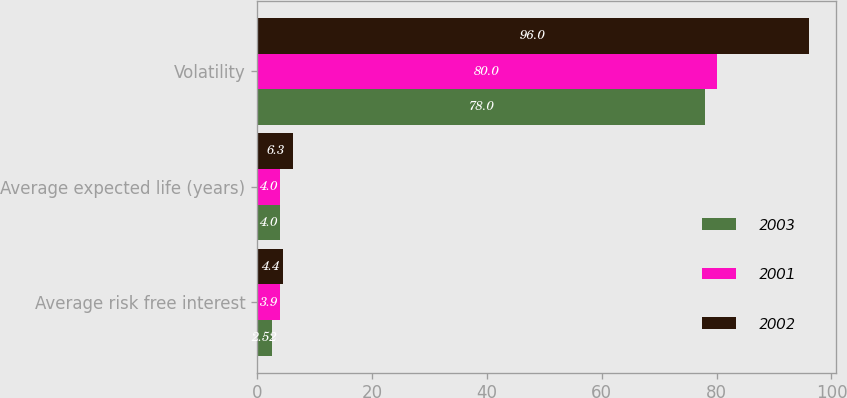Convert chart to OTSL. <chart><loc_0><loc_0><loc_500><loc_500><stacked_bar_chart><ecel><fcel>Average risk free interest<fcel>Average expected life (years)<fcel>Volatility<nl><fcel>2003<fcel>2.52<fcel>4<fcel>78<nl><fcel>2001<fcel>3.9<fcel>4<fcel>80<nl><fcel>2002<fcel>4.4<fcel>6.3<fcel>96<nl></chart> 